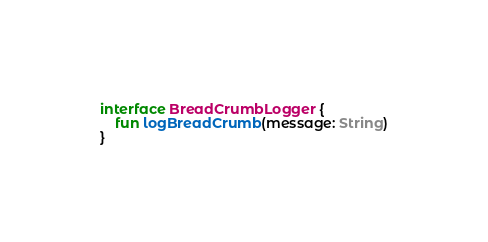<code> <loc_0><loc_0><loc_500><loc_500><_Kotlin_>interface BreadCrumbLogger {
    fun logBreadCrumb(message: String)
}
</code> 